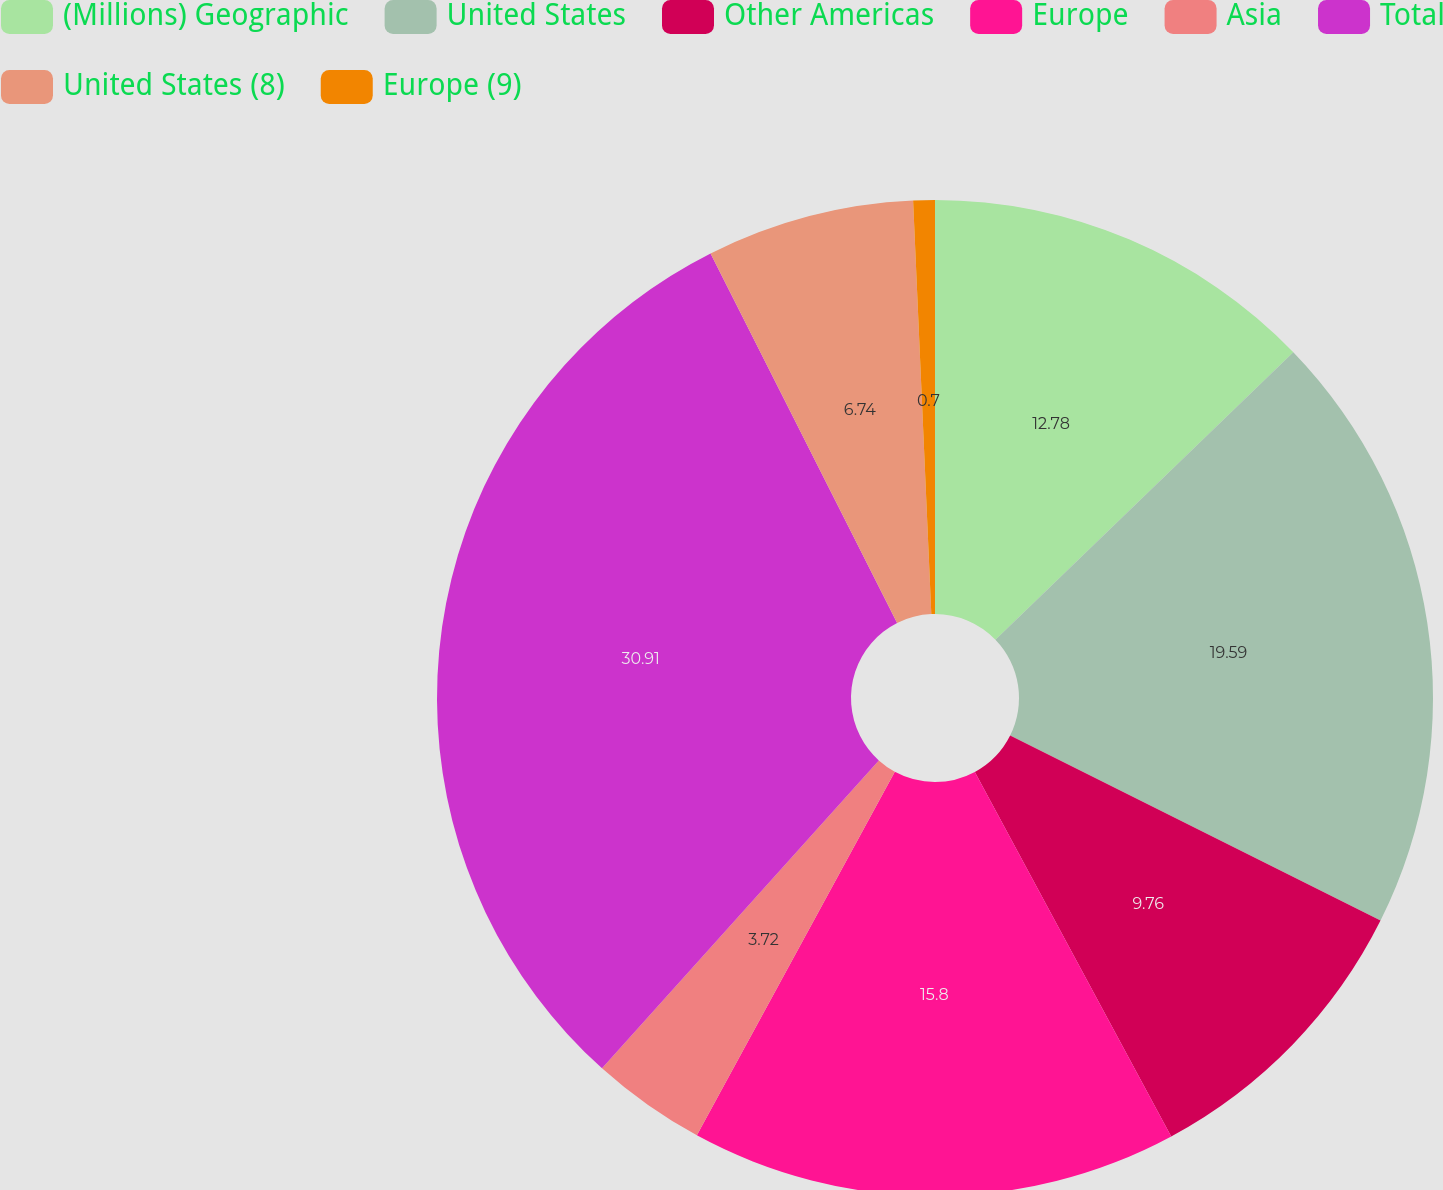<chart> <loc_0><loc_0><loc_500><loc_500><pie_chart><fcel>(Millions) Geographic<fcel>United States<fcel>Other Americas<fcel>Europe<fcel>Asia<fcel>Total<fcel>United States (8)<fcel>Europe (9)<nl><fcel>12.78%<fcel>19.59%<fcel>9.76%<fcel>15.8%<fcel>3.72%<fcel>30.9%<fcel>6.74%<fcel>0.7%<nl></chart> 